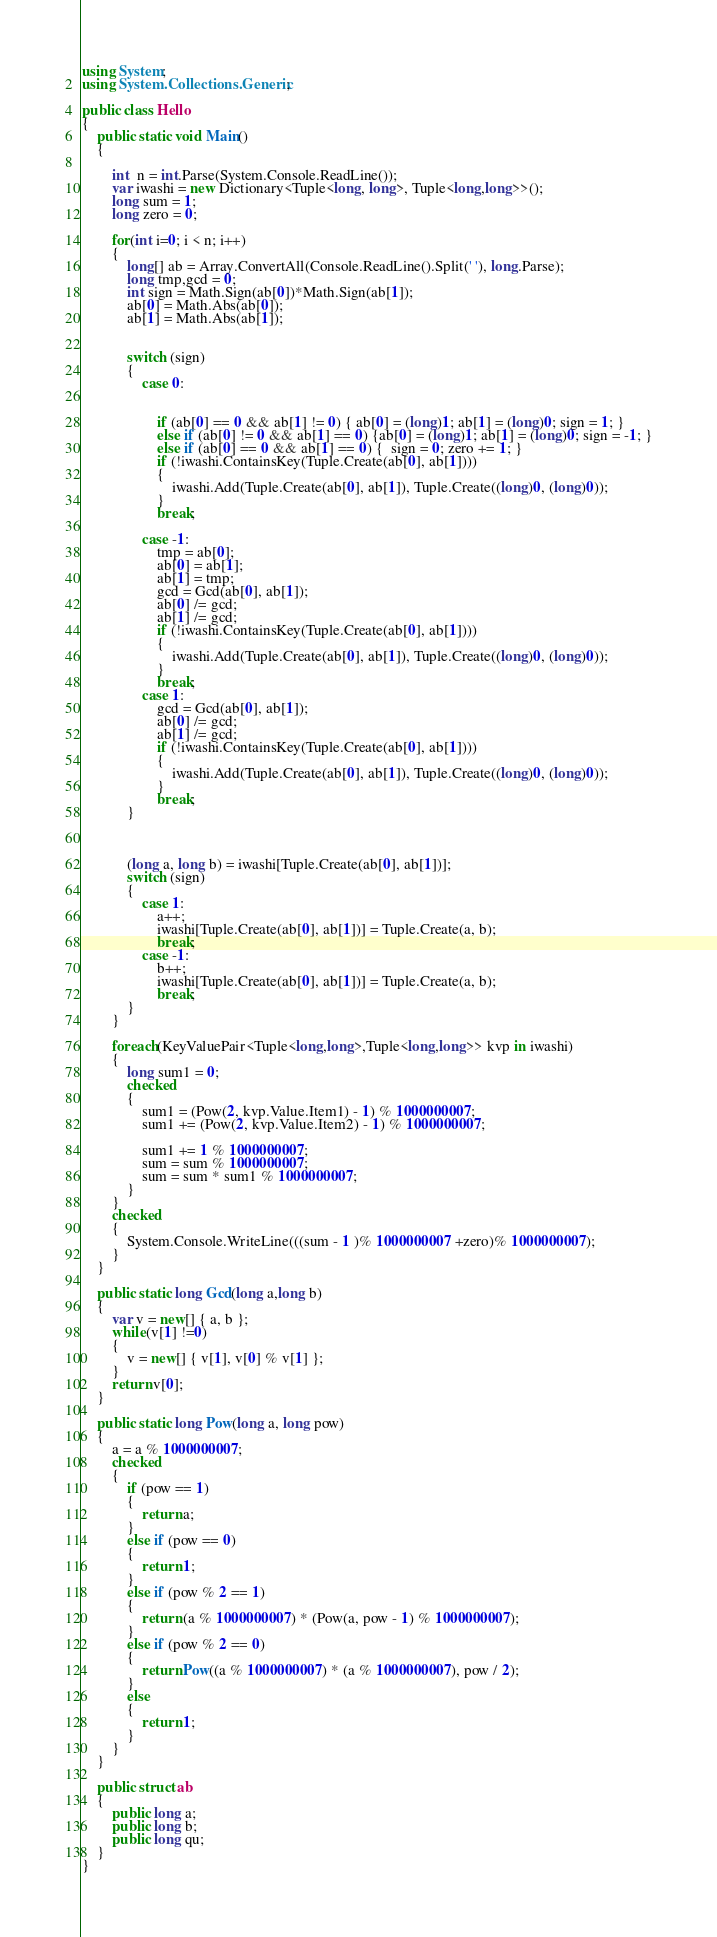Convert code to text. <code><loc_0><loc_0><loc_500><loc_500><_C#_>using System;
using System.Collections.Generic;

public class Hello
{
    public static void Main()
    {

        int  n = int.Parse(System.Console.ReadLine());
        var iwashi = new Dictionary<Tuple<long, long>, Tuple<long,long>>();
        long sum = 1;
        long zero = 0;

        for(int i=0; i < n; i++)
        {
            long[] ab = Array.ConvertAll(Console.ReadLine().Split(' '), long.Parse);
            long tmp,gcd = 0;
            int sign = Math.Sign(ab[0])*Math.Sign(ab[1]);
            ab[0] = Math.Abs(ab[0]);
            ab[1] = Math.Abs(ab[1]);


            switch (sign)
            {
                case 0:


                    if (ab[0] == 0 && ab[1] != 0) { ab[0] = (long)1; ab[1] = (long)0; sign = 1; }
                    else if (ab[0] != 0 && ab[1] == 0) {ab[0] = (long)1; ab[1] = (long)0; sign = -1; }
                    else if (ab[0] == 0 && ab[1] == 0) {  sign = 0; zero += 1; }
                    if (!iwashi.ContainsKey(Tuple.Create(ab[0], ab[1])))
                    {
                        iwashi.Add(Tuple.Create(ab[0], ab[1]), Tuple.Create((long)0, (long)0));
                    }
                    break;

                case -1:
                    tmp = ab[0];
                    ab[0] = ab[1];
                    ab[1] = tmp;
                    gcd = Gcd(ab[0], ab[1]);
                    ab[0] /= gcd;
                    ab[1] /= gcd;
                    if (!iwashi.ContainsKey(Tuple.Create(ab[0], ab[1])))
                    {
                        iwashi.Add(Tuple.Create(ab[0], ab[1]), Tuple.Create((long)0, (long)0));
                    }
                    break;
                case 1:
                    gcd = Gcd(ab[0], ab[1]);
                    ab[0] /= gcd;
                    ab[1] /= gcd;
                    if (!iwashi.ContainsKey(Tuple.Create(ab[0], ab[1])))
                    {
                        iwashi.Add(Tuple.Create(ab[0], ab[1]), Tuple.Create((long)0, (long)0));
                    }
                    break;
            }



            (long a, long b) = iwashi[Tuple.Create(ab[0], ab[1])];
            switch (sign)
            {
                case 1:
                    a++;
                    iwashi[Tuple.Create(ab[0], ab[1])] = Tuple.Create(a, b);
                    break;
                case -1:
                    b++;
                    iwashi[Tuple.Create(ab[0], ab[1])] = Tuple.Create(a, b);
                    break;
            }
        }
        
        foreach(KeyValuePair<Tuple<long,long>,Tuple<long,long>> kvp in iwashi)
        {
            long sum1 = 0;
            checked
            {
                sum1 = (Pow(2, kvp.Value.Item1) - 1) % 1000000007;
                sum1 += (Pow(2, kvp.Value.Item2) - 1) % 1000000007;
          
                sum1 += 1 % 1000000007;
                sum = sum % 1000000007;
                sum = sum * sum1 % 1000000007;
            }
        }
        checked
        {
            System.Console.WriteLine(((sum - 1 )% 1000000007 +zero)% 1000000007);
        }
    }

    public static long Gcd(long a,long b)
    {
        var v = new[] { a, b };
        while(v[1] !=0)
        {
            v = new[] { v[1], v[0] % v[1] };
        }
        return v[0];
    }

    public static long Pow(long a, long pow)
    {
        a = a % 1000000007;
        checked
        {
            if (pow == 1)
            {
                return a;
            }
            else if (pow == 0)
            {
                return 1;
            }
            else if (pow % 2 == 1)
            {
                return (a % 1000000007) * (Pow(a, pow - 1) % 1000000007);
            }
            else if (pow % 2 == 0)
            {
                return Pow((a % 1000000007) * (a % 1000000007), pow / 2);
            }
            else
            {
                return 1;
            }
        }
    }

    public struct ab
    {
        public long a;
        public long b;
        public long qu;
    }
}</code> 